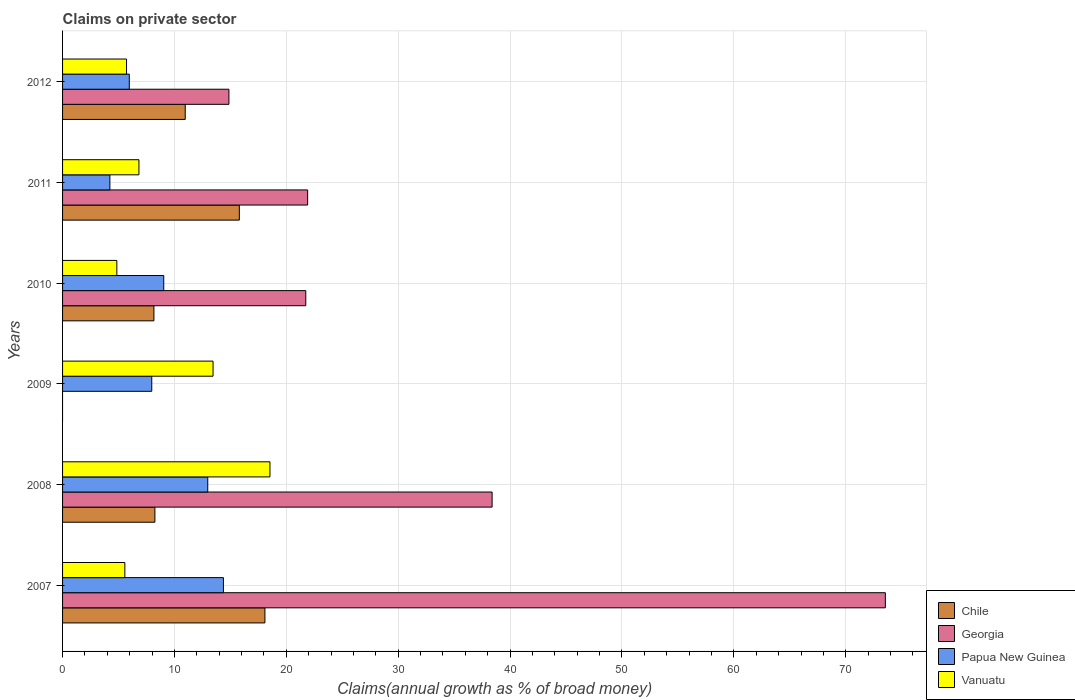How many different coloured bars are there?
Your answer should be compact. 4. How many groups of bars are there?
Your response must be concise. 6. Are the number of bars per tick equal to the number of legend labels?
Provide a short and direct response. No. Are the number of bars on each tick of the Y-axis equal?
Your answer should be compact. No. How many bars are there on the 2nd tick from the bottom?
Offer a terse response. 4. What is the percentage of broad money claimed on private sector in Georgia in 2008?
Give a very brief answer. 38.39. Across all years, what is the maximum percentage of broad money claimed on private sector in Papua New Guinea?
Keep it short and to the point. 14.38. Across all years, what is the minimum percentage of broad money claimed on private sector in Vanuatu?
Provide a short and direct response. 4.85. What is the total percentage of broad money claimed on private sector in Georgia in the graph?
Provide a succinct answer. 170.44. What is the difference between the percentage of broad money claimed on private sector in Georgia in 2007 and that in 2012?
Offer a very short reply. 58.67. What is the difference between the percentage of broad money claimed on private sector in Chile in 2008 and the percentage of broad money claimed on private sector in Papua New Guinea in 2007?
Your response must be concise. -6.12. What is the average percentage of broad money claimed on private sector in Vanuatu per year?
Your answer should be compact. 9.16. In the year 2008, what is the difference between the percentage of broad money claimed on private sector in Vanuatu and percentage of broad money claimed on private sector in Chile?
Offer a very short reply. 10.28. In how many years, is the percentage of broad money claimed on private sector in Vanuatu greater than 8 %?
Your response must be concise. 2. What is the ratio of the percentage of broad money claimed on private sector in Chile in 2007 to that in 2011?
Give a very brief answer. 1.14. Is the difference between the percentage of broad money claimed on private sector in Vanuatu in 2007 and 2011 greater than the difference between the percentage of broad money claimed on private sector in Chile in 2007 and 2011?
Your answer should be compact. No. What is the difference between the highest and the second highest percentage of broad money claimed on private sector in Chile?
Provide a short and direct response. 2.29. What is the difference between the highest and the lowest percentage of broad money claimed on private sector in Papua New Guinea?
Your answer should be compact. 10.15. In how many years, is the percentage of broad money claimed on private sector in Chile greater than the average percentage of broad money claimed on private sector in Chile taken over all years?
Your answer should be compact. 3. Is the sum of the percentage of broad money claimed on private sector in Papua New Guinea in 2008 and 2010 greater than the maximum percentage of broad money claimed on private sector in Chile across all years?
Your answer should be very brief. Yes. Is it the case that in every year, the sum of the percentage of broad money claimed on private sector in Georgia and percentage of broad money claimed on private sector in Papua New Guinea is greater than the sum of percentage of broad money claimed on private sector in Chile and percentage of broad money claimed on private sector in Vanuatu?
Your answer should be compact. No. Is it the case that in every year, the sum of the percentage of broad money claimed on private sector in Vanuatu and percentage of broad money claimed on private sector in Papua New Guinea is greater than the percentage of broad money claimed on private sector in Georgia?
Your response must be concise. No. Are all the bars in the graph horizontal?
Your answer should be very brief. Yes. How many years are there in the graph?
Provide a succinct answer. 6. Are the values on the major ticks of X-axis written in scientific E-notation?
Provide a succinct answer. No. Does the graph contain any zero values?
Make the answer very short. Yes. Where does the legend appear in the graph?
Your answer should be compact. Bottom right. What is the title of the graph?
Give a very brief answer. Claims on private sector. What is the label or title of the X-axis?
Give a very brief answer. Claims(annual growth as % of broad money). What is the label or title of the Y-axis?
Your answer should be compact. Years. What is the Claims(annual growth as % of broad money) in Chile in 2007?
Keep it short and to the point. 18.09. What is the Claims(annual growth as % of broad money) in Georgia in 2007?
Give a very brief answer. 73.54. What is the Claims(annual growth as % of broad money) in Papua New Guinea in 2007?
Your answer should be very brief. 14.38. What is the Claims(annual growth as % of broad money) of Vanuatu in 2007?
Give a very brief answer. 5.57. What is the Claims(annual growth as % of broad money) of Chile in 2008?
Provide a succinct answer. 8.25. What is the Claims(annual growth as % of broad money) of Georgia in 2008?
Offer a terse response. 38.39. What is the Claims(annual growth as % of broad money) of Papua New Guinea in 2008?
Make the answer very short. 12.98. What is the Claims(annual growth as % of broad money) in Vanuatu in 2008?
Your answer should be compact. 18.54. What is the Claims(annual growth as % of broad money) in Papua New Guinea in 2009?
Offer a very short reply. 7.97. What is the Claims(annual growth as % of broad money) in Vanuatu in 2009?
Give a very brief answer. 13.45. What is the Claims(annual growth as % of broad money) in Chile in 2010?
Your response must be concise. 8.16. What is the Claims(annual growth as % of broad money) in Georgia in 2010?
Keep it short and to the point. 21.74. What is the Claims(annual growth as % of broad money) in Papua New Guinea in 2010?
Provide a succinct answer. 9.04. What is the Claims(annual growth as % of broad money) in Vanuatu in 2010?
Your answer should be compact. 4.85. What is the Claims(annual growth as % of broad money) in Chile in 2011?
Provide a short and direct response. 15.8. What is the Claims(annual growth as % of broad money) in Georgia in 2011?
Give a very brief answer. 21.9. What is the Claims(annual growth as % of broad money) in Papua New Guinea in 2011?
Offer a very short reply. 4.23. What is the Claims(annual growth as % of broad money) of Vanuatu in 2011?
Offer a terse response. 6.83. What is the Claims(annual growth as % of broad money) of Chile in 2012?
Offer a terse response. 10.96. What is the Claims(annual growth as % of broad money) in Georgia in 2012?
Ensure brevity in your answer.  14.87. What is the Claims(annual growth as % of broad money) in Papua New Guinea in 2012?
Give a very brief answer. 5.96. What is the Claims(annual growth as % of broad money) of Vanuatu in 2012?
Ensure brevity in your answer.  5.72. Across all years, what is the maximum Claims(annual growth as % of broad money) in Chile?
Your response must be concise. 18.09. Across all years, what is the maximum Claims(annual growth as % of broad money) of Georgia?
Provide a short and direct response. 73.54. Across all years, what is the maximum Claims(annual growth as % of broad money) in Papua New Guinea?
Your answer should be very brief. 14.38. Across all years, what is the maximum Claims(annual growth as % of broad money) of Vanuatu?
Offer a very short reply. 18.54. Across all years, what is the minimum Claims(annual growth as % of broad money) in Papua New Guinea?
Your response must be concise. 4.23. Across all years, what is the minimum Claims(annual growth as % of broad money) in Vanuatu?
Provide a short and direct response. 4.85. What is the total Claims(annual growth as % of broad money) of Chile in the graph?
Make the answer very short. 61.27. What is the total Claims(annual growth as % of broad money) of Georgia in the graph?
Ensure brevity in your answer.  170.44. What is the total Claims(annual growth as % of broad money) in Papua New Guinea in the graph?
Ensure brevity in your answer.  54.56. What is the total Claims(annual growth as % of broad money) in Vanuatu in the graph?
Offer a very short reply. 54.95. What is the difference between the Claims(annual growth as % of broad money) in Chile in 2007 and that in 2008?
Your response must be concise. 9.83. What is the difference between the Claims(annual growth as % of broad money) of Georgia in 2007 and that in 2008?
Keep it short and to the point. 35.15. What is the difference between the Claims(annual growth as % of broad money) in Papua New Guinea in 2007 and that in 2008?
Keep it short and to the point. 1.4. What is the difference between the Claims(annual growth as % of broad money) in Vanuatu in 2007 and that in 2008?
Provide a short and direct response. -12.97. What is the difference between the Claims(annual growth as % of broad money) of Papua New Guinea in 2007 and that in 2009?
Your answer should be compact. 6.41. What is the difference between the Claims(annual growth as % of broad money) in Vanuatu in 2007 and that in 2009?
Offer a terse response. -7.88. What is the difference between the Claims(annual growth as % of broad money) in Chile in 2007 and that in 2010?
Provide a succinct answer. 9.92. What is the difference between the Claims(annual growth as % of broad money) in Georgia in 2007 and that in 2010?
Offer a terse response. 51.8. What is the difference between the Claims(annual growth as % of broad money) in Papua New Guinea in 2007 and that in 2010?
Ensure brevity in your answer.  5.33. What is the difference between the Claims(annual growth as % of broad money) in Vanuatu in 2007 and that in 2010?
Keep it short and to the point. 0.71. What is the difference between the Claims(annual growth as % of broad money) in Chile in 2007 and that in 2011?
Make the answer very short. 2.29. What is the difference between the Claims(annual growth as % of broad money) in Georgia in 2007 and that in 2011?
Your answer should be very brief. 51.64. What is the difference between the Claims(annual growth as % of broad money) of Papua New Guinea in 2007 and that in 2011?
Your answer should be very brief. 10.15. What is the difference between the Claims(annual growth as % of broad money) in Vanuatu in 2007 and that in 2011?
Provide a succinct answer. -1.26. What is the difference between the Claims(annual growth as % of broad money) in Chile in 2007 and that in 2012?
Keep it short and to the point. 7.12. What is the difference between the Claims(annual growth as % of broad money) in Georgia in 2007 and that in 2012?
Keep it short and to the point. 58.67. What is the difference between the Claims(annual growth as % of broad money) in Papua New Guinea in 2007 and that in 2012?
Ensure brevity in your answer.  8.41. What is the difference between the Claims(annual growth as % of broad money) in Vanuatu in 2007 and that in 2012?
Your answer should be very brief. -0.15. What is the difference between the Claims(annual growth as % of broad money) of Papua New Guinea in 2008 and that in 2009?
Make the answer very short. 5. What is the difference between the Claims(annual growth as % of broad money) of Vanuatu in 2008 and that in 2009?
Keep it short and to the point. 5.09. What is the difference between the Claims(annual growth as % of broad money) in Chile in 2008 and that in 2010?
Your response must be concise. 0.09. What is the difference between the Claims(annual growth as % of broad money) in Georgia in 2008 and that in 2010?
Offer a very short reply. 16.65. What is the difference between the Claims(annual growth as % of broad money) in Papua New Guinea in 2008 and that in 2010?
Your answer should be compact. 3.93. What is the difference between the Claims(annual growth as % of broad money) in Vanuatu in 2008 and that in 2010?
Offer a terse response. 13.68. What is the difference between the Claims(annual growth as % of broad money) of Chile in 2008 and that in 2011?
Keep it short and to the point. -7.55. What is the difference between the Claims(annual growth as % of broad money) of Georgia in 2008 and that in 2011?
Keep it short and to the point. 16.49. What is the difference between the Claims(annual growth as % of broad money) in Papua New Guinea in 2008 and that in 2011?
Your answer should be very brief. 8.75. What is the difference between the Claims(annual growth as % of broad money) in Vanuatu in 2008 and that in 2011?
Give a very brief answer. 11.71. What is the difference between the Claims(annual growth as % of broad money) of Chile in 2008 and that in 2012?
Offer a terse response. -2.71. What is the difference between the Claims(annual growth as % of broad money) of Georgia in 2008 and that in 2012?
Your answer should be very brief. 23.52. What is the difference between the Claims(annual growth as % of broad money) in Papua New Guinea in 2008 and that in 2012?
Your answer should be compact. 7.01. What is the difference between the Claims(annual growth as % of broad money) of Vanuatu in 2008 and that in 2012?
Provide a succinct answer. 12.82. What is the difference between the Claims(annual growth as % of broad money) of Papua New Guinea in 2009 and that in 2010?
Offer a very short reply. -1.07. What is the difference between the Claims(annual growth as % of broad money) in Vanuatu in 2009 and that in 2010?
Your response must be concise. 8.6. What is the difference between the Claims(annual growth as % of broad money) in Papua New Guinea in 2009 and that in 2011?
Offer a terse response. 3.74. What is the difference between the Claims(annual growth as % of broad money) of Vanuatu in 2009 and that in 2011?
Provide a succinct answer. 6.62. What is the difference between the Claims(annual growth as % of broad money) of Papua New Guinea in 2009 and that in 2012?
Your answer should be very brief. 2.01. What is the difference between the Claims(annual growth as % of broad money) in Vanuatu in 2009 and that in 2012?
Ensure brevity in your answer.  7.73. What is the difference between the Claims(annual growth as % of broad money) of Chile in 2010 and that in 2011?
Provide a succinct answer. -7.63. What is the difference between the Claims(annual growth as % of broad money) of Georgia in 2010 and that in 2011?
Give a very brief answer. -0.17. What is the difference between the Claims(annual growth as % of broad money) in Papua New Guinea in 2010 and that in 2011?
Your answer should be compact. 4.81. What is the difference between the Claims(annual growth as % of broad money) in Vanuatu in 2010 and that in 2011?
Provide a short and direct response. -1.97. What is the difference between the Claims(annual growth as % of broad money) of Chile in 2010 and that in 2012?
Make the answer very short. -2.8. What is the difference between the Claims(annual growth as % of broad money) in Georgia in 2010 and that in 2012?
Provide a short and direct response. 6.87. What is the difference between the Claims(annual growth as % of broad money) of Papua New Guinea in 2010 and that in 2012?
Make the answer very short. 3.08. What is the difference between the Claims(annual growth as % of broad money) of Vanuatu in 2010 and that in 2012?
Make the answer very short. -0.87. What is the difference between the Claims(annual growth as % of broad money) in Chile in 2011 and that in 2012?
Give a very brief answer. 4.84. What is the difference between the Claims(annual growth as % of broad money) of Georgia in 2011 and that in 2012?
Your response must be concise. 7.04. What is the difference between the Claims(annual growth as % of broad money) in Papua New Guinea in 2011 and that in 2012?
Your answer should be very brief. -1.73. What is the difference between the Claims(annual growth as % of broad money) in Vanuatu in 2011 and that in 2012?
Ensure brevity in your answer.  1.11. What is the difference between the Claims(annual growth as % of broad money) in Chile in 2007 and the Claims(annual growth as % of broad money) in Georgia in 2008?
Keep it short and to the point. -20.31. What is the difference between the Claims(annual growth as % of broad money) in Chile in 2007 and the Claims(annual growth as % of broad money) in Papua New Guinea in 2008?
Make the answer very short. 5.11. What is the difference between the Claims(annual growth as % of broad money) in Chile in 2007 and the Claims(annual growth as % of broad money) in Vanuatu in 2008?
Ensure brevity in your answer.  -0.45. What is the difference between the Claims(annual growth as % of broad money) of Georgia in 2007 and the Claims(annual growth as % of broad money) of Papua New Guinea in 2008?
Your response must be concise. 60.56. What is the difference between the Claims(annual growth as % of broad money) of Georgia in 2007 and the Claims(annual growth as % of broad money) of Vanuatu in 2008?
Offer a terse response. 55. What is the difference between the Claims(annual growth as % of broad money) in Papua New Guinea in 2007 and the Claims(annual growth as % of broad money) in Vanuatu in 2008?
Your response must be concise. -4.16. What is the difference between the Claims(annual growth as % of broad money) in Chile in 2007 and the Claims(annual growth as % of broad money) in Papua New Guinea in 2009?
Offer a terse response. 10.11. What is the difference between the Claims(annual growth as % of broad money) in Chile in 2007 and the Claims(annual growth as % of broad money) in Vanuatu in 2009?
Provide a short and direct response. 4.64. What is the difference between the Claims(annual growth as % of broad money) in Georgia in 2007 and the Claims(annual growth as % of broad money) in Papua New Guinea in 2009?
Your response must be concise. 65.57. What is the difference between the Claims(annual growth as % of broad money) of Georgia in 2007 and the Claims(annual growth as % of broad money) of Vanuatu in 2009?
Provide a short and direct response. 60.09. What is the difference between the Claims(annual growth as % of broad money) in Papua New Guinea in 2007 and the Claims(annual growth as % of broad money) in Vanuatu in 2009?
Offer a very short reply. 0.93. What is the difference between the Claims(annual growth as % of broad money) in Chile in 2007 and the Claims(annual growth as % of broad money) in Georgia in 2010?
Your answer should be compact. -3.65. What is the difference between the Claims(annual growth as % of broad money) in Chile in 2007 and the Claims(annual growth as % of broad money) in Papua New Guinea in 2010?
Keep it short and to the point. 9.04. What is the difference between the Claims(annual growth as % of broad money) in Chile in 2007 and the Claims(annual growth as % of broad money) in Vanuatu in 2010?
Provide a succinct answer. 13.23. What is the difference between the Claims(annual growth as % of broad money) in Georgia in 2007 and the Claims(annual growth as % of broad money) in Papua New Guinea in 2010?
Provide a short and direct response. 64.5. What is the difference between the Claims(annual growth as % of broad money) of Georgia in 2007 and the Claims(annual growth as % of broad money) of Vanuatu in 2010?
Provide a succinct answer. 68.69. What is the difference between the Claims(annual growth as % of broad money) of Papua New Guinea in 2007 and the Claims(annual growth as % of broad money) of Vanuatu in 2010?
Provide a short and direct response. 9.53. What is the difference between the Claims(annual growth as % of broad money) in Chile in 2007 and the Claims(annual growth as % of broad money) in Georgia in 2011?
Provide a short and direct response. -3.82. What is the difference between the Claims(annual growth as % of broad money) of Chile in 2007 and the Claims(annual growth as % of broad money) of Papua New Guinea in 2011?
Provide a succinct answer. 13.86. What is the difference between the Claims(annual growth as % of broad money) of Chile in 2007 and the Claims(annual growth as % of broad money) of Vanuatu in 2011?
Offer a very short reply. 11.26. What is the difference between the Claims(annual growth as % of broad money) in Georgia in 2007 and the Claims(annual growth as % of broad money) in Papua New Guinea in 2011?
Offer a terse response. 69.31. What is the difference between the Claims(annual growth as % of broad money) in Georgia in 2007 and the Claims(annual growth as % of broad money) in Vanuatu in 2011?
Make the answer very short. 66.71. What is the difference between the Claims(annual growth as % of broad money) in Papua New Guinea in 2007 and the Claims(annual growth as % of broad money) in Vanuatu in 2011?
Your answer should be compact. 7.55. What is the difference between the Claims(annual growth as % of broad money) of Chile in 2007 and the Claims(annual growth as % of broad money) of Georgia in 2012?
Make the answer very short. 3.22. What is the difference between the Claims(annual growth as % of broad money) in Chile in 2007 and the Claims(annual growth as % of broad money) in Papua New Guinea in 2012?
Ensure brevity in your answer.  12.12. What is the difference between the Claims(annual growth as % of broad money) in Chile in 2007 and the Claims(annual growth as % of broad money) in Vanuatu in 2012?
Your response must be concise. 12.37. What is the difference between the Claims(annual growth as % of broad money) of Georgia in 2007 and the Claims(annual growth as % of broad money) of Papua New Guinea in 2012?
Make the answer very short. 67.58. What is the difference between the Claims(annual growth as % of broad money) of Georgia in 2007 and the Claims(annual growth as % of broad money) of Vanuatu in 2012?
Make the answer very short. 67.82. What is the difference between the Claims(annual growth as % of broad money) of Papua New Guinea in 2007 and the Claims(annual growth as % of broad money) of Vanuatu in 2012?
Keep it short and to the point. 8.66. What is the difference between the Claims(annual growth as % of broad money) in Chile in 2008 and the Claims(annual growth as % of broad money) in Papua New Guinea in 2009?
Provide a short and direct response. 0.28. What is the difference between the Claims(annual growth as % of broad money) of Chile in 2008 and the Claims(annual growth as % of broad money) of Vanuatu in 2009?
Your answer should be compact. -5.2. What is the difference between the Claims(annual growth as % of broad money) of Georgia in 2008 and the Claims(annual growth as % of broad money) of Papua New Guinea in 2009?
Provide a succinct answer. 30.42. What is the difference between the Claims(annual growth as % of broad money) in Georgia in 2008 and the Claims(annual growth as % of broad money) in Vanuatu in 2009?
Give a very brief answer. 24.94. What is the difference between the Claims(annual growth as % of broad money) in Papua New Guinea in 2008 and the Claims(annual growth as % of broad money) in Vanuatu in 2009?
Provide a succinct answer. -0.47. What is the difference between the Claims(annual growth as % of broad money) of Chile in 2008 and the Claims(annual growth as % of broad money) of Georgia in 2010?
Make the answer very short. -13.48. What is the difference between the Claims(annual growth as % of broad money) in Chile in 2008 and the Claims(annual growth as % of broad money) in Papua New Guinea in 2010?
Offer a very short reply. -0.79. What is the difference between the Claims(annual growth as % of broad money) in Chile in 2008 and the Claims(annual growth as % of broad money) in Vanuatu in 2010?
Your answer should be compact. 3.4. What is the difference between the Claims(annual growth as % of broad money) of Georgia in 2008 and the Claims(annual growth as % of broad money) of Papua New Guinea in 2010?
Your response must be concise. 29.35. What is the difference between the Claims(annual growth as % of broad money) in Georgia in 2008 and the Claims(annual growth as % of broad money) in Vanuatu in 2010?
Ensure brevity in your answer.  33.54. What is the difference between the Claims(annual growth as % of broad money) of Papua New Guinea in 2008 and the Claims(annual growth as % of broad money) of Vanuatu in 2010?
Make the answer very short. 8.12. What is the difference between the Claims(annual growth as % of broad money) in Chile in 2008 and the Claims(annual growth as % of broad money) in Georgia in 2011?
Offer a very short reply. -13.65. What is the difference between the Claims(annual growth as % of broad money) of Chile in 2008 and the Claims(annual growth as % of broad money) of Papua New Guinea in 2011?
Provide a short and direct response. 4.02. What is the difference between the Claims(annual growth as % of broad money) of Chile in 2008 and the Claims(annual growth as % of broad money) of Vanuatu in 2011?
Provide a succinct answer. 1.43. What is the difference between the Claims(annual growth as % of broad money) of Georgia in 2008 and the Claims(annual growth as % of broad money) of Papua New Guinea in 2011?
Your response must be concise. 34.16. What is the difference between the Claims(annual growth as % of broad money) in Georgia in 2008 and the Claims(annual growth as % of broad money) in Vanuatu in 2011?
Provide a short and direct response. 31.57. What is the difference between the Claims(annual growth as % of broad money) in Papua New Guinea in 2008 and the Claims(annual growth as % of broad money) in Vanuatu in 2011?
Provide a succinct answer. 6.15. What is the difference between the Claims(annual growth as % of broad money) in Chile in 2008 and the Claims(annual growth as % of broad money) in Georgia in 2012?
Give a very brief answer. -6.61. What is the difference between the Claims(annual growth as % of broad money) in Chile in 2008 and the Claims(annual growth as % of broad money) in Papua New Guinea in 2012?
Make the answer very short. 2.29. What is the difference between the Claims(annual growth as % of broad money) of Chile in 2008 and the Claims(annual growth as % of broad money) of Vanuatu in 2012?
Your response must be concise. 2.54. What is the difference between the Claims(annual growth as % of broad money) in Georgia in 2008 and the Claims(annual growth as % of broad money) in Papua New Guinea in 2012?
Ensure brevity in your answer.  32.43. What is the difference between the Claims(annual growth as % of broad money) in Georgia in 2008 and the Claims(annual growth as % of broad money) in Vanuatu in 2012?
Provide a short and direct response. 32.67. What is the difference between the Claims(annual growth as % of broad money) in Papua New Guinea in 2008 and the Claims(annual growth as % of broad money) in Vanuatu in 2012?
Your answer should be very brief. 7.26. What is the difference between the Claims(annual growth as % of broad money) in Papua New Guinea in 2009 and the Claims(annual growth as % of broad money) in Vanuatu in 2010?
Provide a short and direct response. 3.12. What is the difference between the Claims(annual growth as % of broad money) of Papua New Guinea in 2009 and the Claims(annual growth as % of broad money) of Vanuatu in 2011?
Make the answer very short. 1.15. What is the difference between the Claims(annual growth as % of broad money) in Papua New Guinea in 2009 and the Claims(annual growth as % of broad money) in Vanuatu in 2012?
Offer a very short reply. 2.25. What is the difference between the Claims(annual growth as % of broad money) in Chile in 2010 and the Claims(annual growth as % of broad money) in Georgia in 2011?
Provide a succinct answer. -13.74. What is the difference between the Claims(annual growth as % of broad money) in Chile in 2010 and the Claims(annual growth as % of broad money) in Papua New Guinea in 2011?
Provide a short and direct response. 3.93. What is the difference between the Claims(annual growth as % of broad money) in Chile in 2010 and the Claims(annual growth as % of broad money) in Vanuatu in 2011?
Your answer should be very brief. 1.34. What is the difference between the Claims(annual growth as % of broad money) in Georgia in 2010 and the Claims(annual growth as % of broad money) in Papua New Guinea in 2011?
Ensure brevity in your answer.  17.51. What is the difference between the Claims(annual growth as % of broad money) of Georgia in 2010 and the Claims(annual growth as % of broad money) of Vanuatu in 2011?
Your response must be concise. 14.91. What is the difference between the Claims(annual growth as % of broad money) of Papua New Guinea in 2010 and the Claims(annual growth as % of broad money) of Vanuatu in 2011?
Provide a succinct answer. 2.22. What is the difference between the Claims(annual growth as % of broad money) in Chile in 2010 and the Claims(annual growth as % of broad money) in Georgia in 2012?
Your answer should be compact. -6.7. What is the difference between the Claims(annual growth as % of broad money) in Chile in 2010 and the Claims(annual growth as % of broad money) in Papua New Guinea in 2012?
Keep it short and to the point. 2.2. What is the difference between the Claims(annual growth as % of broad money) in Chile in 2010 and the Claims(annual growth as % of broad money) in Vanuatu in 2012?
Make the answer very short. 2.45. What is the difference between the Claims(annual growth as % of broad money) of Georgia in 2010 and the Claims(annual growth as % of broad money) of Papua New Guinea in 2012?
Ensure brevity in your answer.  15.77. What is the difference between the Claims(annual growth as % of broad money) in Georgia in 2010 and the Claims(annual growth as % of broad money) in Vanuatu in 2012?
Offer a terse response. 16.02. What is the difference between the Claims(annual growth as % of broad money) of Papua New Guinea in 2010 and the Claims(annual growth as % of broad money) of Vanuatu in 2012?
Your answer should be compact. 3.33. What is the difference between the Claims(annual growth as % of broad money) in Chile in 2011 and the Claims(annual growth as % of broad money) in Georgia in 2012?
Offer a very short reply. 0.93. What is the difference between the Claims(annual growth as % of broad money) in Chile in 2011 and the Claims(annual growth as % of broad money) in Papua New Guinea in 2012?
Your answer should be very brief. 9.84. What is the difference between the Claims(annual growth as % of broad money) of Chile in 2011 and the Claims(annual growth as % of broad money) of Vanuatu in 2012?
Provide a succinct answer. 10.08. What is the difference between the Claims(annual growth as % of broad money) of Georgia in 2011 and the Claims(annual growth as % of broad money) of Papua New Guinea in 2012?
Your answer should be very brief. 15.94. What is the difference between the Claims(annual growth as % of broad money) of Georgia in 2011 and the Claims(annual growth as % of broad money) of Vanuatu in 2012?
Ensure brevity in your answer.  16.19. What is the difference between the Claims(annual growth as % of broad money) in Papua New Guinea in 2011 and the Claims(annual growth as % of broad money) in Vanuatu in 2012?
Your answer should be compact. -1.49. What is the average Claims(annual growth as % of broad money) of Chile per year?
Your response must be concise. 10.21. What is the average Claims(annual growth as % of broad money) of Georgia per year?
Give a very brief answer. 28.41. What is the average Claims(annual growth as % of broad money) of Papua New Guinea per year?
Make the answer very short. 9.09. What is the average Claims(annual growth as % of broad money) of Vanuatu per year?
Your answer should be very brief. 9.16. In the year 2007, what is the difference between the Claims(annual growth as % of broad money) of Chile and Claims(annual growth as % of broad money) of Georgia?
Your answer should be very brief. -55.45. In the year 2007, what is the difference between the Claims(annual growth as % of broad money) of Chile and Claims(annual growth as % of broad money) of Papua New Guinea?
Make the answer very short. 3.71. In the year 2007, what is the difference between the Claims(annual growth as % of broad money) of Chile and Claims(annual growth as % of broad money) of Vanuatu?
Your answer should be very brief. 12.52. In the year 2007, what is the difference between the Claims(annual growth as % of broad money) in Georgia and Claims(annual growth as % of broad money) in Papua New Guinea?
Your answer should be compact. 59.16. In the year 2007, what is the difference between the Claims(annual growth as % of broad money) in Georgia and Claims(annual growth as % of broad money) in Vanuatu?
Offer a terse response. 67.97. In the year 2007, what is the difference between the Claims(annual growth as % of broad money) of Papua New Guinea and Claims(annual growth as % of broad money) of Vanuatu?
Provide a succinct answer. 8.81. In the year 2008, what is the difference between the Claims(annual growth as % of broad money) in Chile and Claims(annual growth as % of broad money) in Georgia?
Provide a short and direct response. -30.14. In the year 2008, what is the difference between the Claims(annual growth as % of broad money) in Chile and Claims(annual growth as % of broad money) in Papua New Guinea?
Provide a short and direct response. -4.72. In the year 2008, what is the difference between the Claims(annual growth as % of broad money) in Chile and Claims(annual growth as % of broad money) in Vanuatu?
Provide a short and direct response. -10.28. In the year 2008, what is the difference between the Claims(annual growth as % of broad money) in Georgia and Claims(annual growth as % of broad money) in Papua New Guinea?
Give a very brief answer. 25.42. In the year 2008, what is the difference between the Claims(annual growth as % of broad money) of Georgia and Claims(annual growth as % of broad money) of Vanuatu?
Give a very brief answer. 19.86. In the year 2008, what is the difference between the Claims(annual growth as % of broad money) in Papua New Guinea and Claims(annual growth as % of broad money) in Vanuatu?
Ensure brevity in your answer.  -5.56. In the year 2009, what is the difference between the Claims(annual growth as % of broad money) in Papua New Guinea and Claims(annual growth as % of broad money) in Vanuatu?
Ensure brevity in your answer.  -5.48. In the year 2010, what is the difference between the Claims(annual growth as % of broad money) of Chile and Claims(annual growth as % of broad money) of Georgia?
Your answer should be very brief. -13.57. In the year 2010, what is the difference between the Claims(annual growth as % of broad money) in Chile and Claims(annual growth as % of broad money) in Papua New Guinea?
Provide a succinct answer. -0.88. In the year 2010, what is the difference between the Claims(annual growth as % of broad money) of Chile and Claims(annual growth as % of broad money) of Vanuatu?
Offer a terse response. 3.31. In the year 2010, what is the difference between the Claims(annual growth as % of broad money) of Georgia and Claims(annual growth as % of broad money) of Papua New Guinea?
Your answer should be compact. 12.69. In the year 2010, what is the difference between the Claims(annual growth as % of broad money) of Georgia and Claims(annual growth as % of broad money) of Vanuatu?
Offer a very short reply. 16.89. In the year 2010, what is the difference between the Claims(annual growth as % of broad money) of Papua New Guinea and Claims(annual growth as % of broad money) of Vanuatu?
Your answer should be very brief. 4.19. In the year 2011, what is the difference between the Claims(annual growth as % of broad money) of Chile and Claims(annual growth as % of broad money) of Georgia?
Your answer should be very brief. -6.1. In the year 2011, what is the difference between the Claims(annual growth as % of broad money) of Chile and Claims(annual growth as % of broad money) of Papua New Guinea?
Provide a short and direct response. 11.57. In the year 2011, what is the difference between the Claims(annual growth as % of broad money) in Chile and Claims(annual growth as % of broad money) in Vanuatu?
Offer a very short reply. 8.97. In the year 2011, what is the difference between the Claims(annual growth as % of broad money) of Georgia and Claims(annual growth as % of broad money) of Papua New Guinea?
Your answer should be compact. 17.67. In the year 2011, what is the difference between the Claims(annual growth as % of broad money) of Georgia and Claims(annual growth as % of broad money) of Vanuatu?
Keep it short and to the point. 15.08. In the year 2011, what is the difference between the Claims(annual growth as % of broad money) in Papua New Guinea and Claims(annual growth as % of broad money) in Vanuatu?
Offer a very short reply. -2.6. In the year 2012, what is the difference between the Claims(annual growth as % of broad money) of Chile and Claims(annual growth as % of broad money) of Georgia?
Provide a short and direct response. -3.9. In the year 2012, what is the difference between the Claims(annual growth as % of broad money) of Chile and Claims(annual growth as % of broad money) of Papua New Guinea?
Give a very brief answer. 5. In the year 2012, what is the difference between the Claims(annual growth as % of broad money) of Chile and Claims(annual growth as % of broad money) of Vanuatu?
Offer a terse response. 5.25. In the year 2012, what is the difference between the Claims(annual growth as % of broad money) in Georgia and Claims(annual growth as % of broad money) in Papua New Guinea?
Your answer should be very brief. 8.9. In the year 2012, what is the difference between the Claims(annual growth as % of broad money) of Georgia and Claims(annual growth as % of broad money) of Vanuatu?
Your answer should be very brief. 9.15. In the year 2012, what is the difference between the Claims(annual growth as % of broad money) of Papua New Guinea and Claims(annual growth as % of broad money) of Vanuatu?
Your answer should be compact. 0.25. What is the ratio of the Claims(annual growth as % of broad money) of Chile in 2007 to that in 2008?
Ensure brevity in your answer.  2.19. What is the ratio of the Claims(annual growth as % of broad money) of Georgia in 2007 to that in 2008?
Make the answer very short. 1.92. What is the ratio of the Claims(annual growth as % of broad money) of Papua New Guinea in 2007 to that in 2008?
Offer a terse response. 1.11. What is the ratio of the Claims(annual growth as % of broad money) in Vanuatu in 2007 to that in 2008?
Give a very brief answer. 0.3. What is the ratio of the Claims(annual growth as % of broad money) in Papua New Guinea in 2007 to that in 2009?
Offer a very short reply. 1.8. What is the ratio of the Claims(annual growth as % of broad money) in Vanuatu in 2007 to that in 2009?
Offer a very short reply. 0.41. What is the ratio of the Claims(annual growth as % of broad money) of Chile in 2007 to that in 2010?
Ensure brevity in your answer.  2.21. What is the ratio of the Claims(annual growth as % of broad money) in Georgia in 2007 to that in 2010?
Provide a short and direct response. 3.38. What is the ratio of the Claims(annual growth as % of broad money) of Papua New Guinea in 2007 to that in 2010?
Ensure brevity in your answer.  1.59. What is the ratio of the Claims(annual growth as % of broad money) of Vanuatu in 2007 to that in 2010?
Provide a succinct answer. 1.15. What is the ratio of the Claims(annual growth as % of broad money) of Chile in 2007 to that in 2011?
Provide a succinct answer. 1.14. What is the ratio of the Claims(annual growth as % of broad money) of Georgia in 2007 to that in 2011?
Your answer should be very brief. 3.36. What is the ratio of the Claims(annual growth as % of broad money) in Papua New Guinea in 2007 to that in 2011?
Give a very brief answer. 3.4. What is the ratio of the Claims(annual growth as % of broad money) of Vanuatu in 2007 to that in 2011?
Your response must be concise. 0.82. What is the ratio of the Claims(annual growth as % of broad money) in Chile in 2007 to that in 2012?
Offer a very short reply. 1.65. What is the ratio of the Claims(annual growth as % of broad money) of Georgia in 2007 to that in 2012?
Your answer should be compact. 4.95. What is the ratio of the Claims(annual growth as % of broad money) in Papua New Guinea in 2007 to that in 2012?
Your answer should be compact. 2.41. What is the ratio of the Claims(annual growth as % of broad money) of Vanuatu in 2007 to that in 2012?
Offer a terse response. 0.97. What is the ratio of the Claims(annual growth as % of broad money) of Papua New Guinea in 2008 to that in 2009?
Ensure brevity in your answer.  1.63. What is the ratio of the Claims(annual growth as % of broad money) of Vanuatu in 2008 to that in 2009?
Offer a very short reply. 1.38. What is the ratio of the Claims(annual growth as % of broad money) in Chile in 2008 to that in 2010?
Your answer should be very brief. 1.01. What is the ratio of the Claims(annual growth as % of broad money) of Georgia in 2008 to that in 2010?
Provide a short and direct response. 1.77. What is the ratio of the Claims(annual growth as % of broad money) in Papua New Guinea in 2008 to that in 2010?
Your answer should be compact. 1.43. What is the ratio of the Claims(annual growth as % of broad money) in Vanuatu in 2008 to that in 2010?
Offer a very short reply. 3.82. What is the ratio of the Claims(annual growth as % of broad money) in Chile in 2008 to that in 2011?
Provide a short and direct response. 0.52. What is the ratio of the Claims(annual growth as % of broad money) of Georgia in 2008 to that in 2011?
Your answer should be very brief. 1.75. What is the ratio of the Claims(annual growth as % of broad money) in Papua New Guinea in 2008 to that in 2011?
Your answer should be very brief. 3.07. What is the ratio of the Claims(annual growth as % of broad money) of Vanuatu in 2008 to that in 2011?
Provide a succinct answer. 2.72. What is the ratio of the Claims(annual growth as % of broad money) of Chile in 2008 to that in 2012?
Keep it short and to the point. 0.75. What is the ratio of the Claims(annual growth as % of broad money) of Georgia in 2008 to that in 2012?
Make the answer very short. 2.58. What is the ratio of the Claims(annual growth as % of broad money) of Papua New Guinea in 2008 to that in 2012?
Offer a very short reply. 2.18. What is the ratio of the Claims(annual growth as % of broad money) of Vanuatu in 2008 to that in 2012?
Your response must be concise. 3.24. What is the ratio of the Claims(annual growth as % of broad money) of Papua New Guinea in 2009 to that in 2010?
Provide a short and direct response. 0.88. What is the ratio of the Claims(annual growth as % of broad money) of Vanuatu in 2009 to that in 2010?
Keep it short and to the point. 2.77. What is the ratio of the Claims(annual growth as % of broad money) in Papua New Guinea in 2009 to that in 2011?
Provide a short and direct response. 1.88. What is the ratio of the Claims(annual growth as % of broad money) in Vanuatu in 2009 to that in 2011?
Keep it short and to the point. 1.97. What is the ratio of the Claims(annual growth as % of broad money) of Papua New Guinea in 2009 to that in 2012?
Keep it short and to the point. 1.34. What is the ratio of the Claims(annual growth as % of broad money) of Vanuatu in 2009 to that in 2012?
Your answer should be compact. 2.35. What is the ratio of the Claims(annual growth as % of broad money) of Chile in 2010 to that in 2011?
Make the answer very short. 0.52. What is the ratio of the Claims(annual growth as % of broad money) of Georgia in 2010 to that in 2011?
Your response must be concise. 0.99. What is the ratio of the Claims(annual growth as % of broad money) in Papua New Guinea in 2010 to that in 2011?
Your answer should be very brief. 2.14. What is the ratio of the Claims(annual growth as % of broad money) in Vanuatu in 2010 to that in 2011?
Provide a succinct answer. 0.71. What is the ratio of the Claims(annual growth as % of broad money) of Chile in 2010 to that in 2012?
Give a very brief answer. 0.74. What is the ratio of the Claims(annual growth as % of broad money) in Georgia in 2010 to that in 2012?
Your answer should be compact. 1.46. What is the ratio of the Claims(annual growth as % of broad money) of Papua New Guinea in 2010 to that in 2012?
Ensure brevity in your answer.  1.52. What is the ratio of the Claims(annual growth as % of broad money) in Vanuatu in 2010 to that in 2012?
Your answer should be very brief. 0.85. What is the ratio of the Claims(annual growth as % of broad money) in Chile in 2011 to that in 2012?
Your answer should be compact. 1.44. What is the ratio of the Claims(annual growth as % of broad money) of Georgia in 2011 to that in 2012?
Ensure brevity in your answer.  1.47. What is the ratio of the Claims(annual growth as % of broad money) of Papua New Guinea in 2011 to that in 2012?
Make the answer very short. 0.71. What is the ratio of the Claims(annual growth as % of broad money) of Vanuatu in 2011 to that in 2012?
Make the answer very short. 1.19. What is the difference between the highest and the second highest Claims(annual growth as % of broad money) of Chile?
Keep it short and to the point. 2.29. What is the difference between the highest and the second highest Claims(annual growth as % of broad money) of Georgia?
Provide a short and direct response. 35.15. What is the difference between the highest and the second highest Claims(annual growth as % of broad money) in Papua New Guinea?
Provide a succinct answer. 1.4. What is the difference between the highest and the second highest Claims(annual growth as % of broad money) in Vanuatu?
Your response must be concise. 5.09. What is the difference between the highest and the lowest Claims(annual growth as % of broad money) in Chile?
Your answer should be very brief. 18.09. What is the difference between the highest and the lowest Claims(annual growth as % of broad money) in Georgia?
Your answer should be compact. 73.54. What is the difference between the highest and the lowest Claims(annual growth as % of broad money) of Papua New Guinea?
Provide a succinct answer. 10.15. What is the difference between the highest and the lowest Claims(annual growth as % of broad money) of Vanuatu?
Make the answer very short. 13.68. 